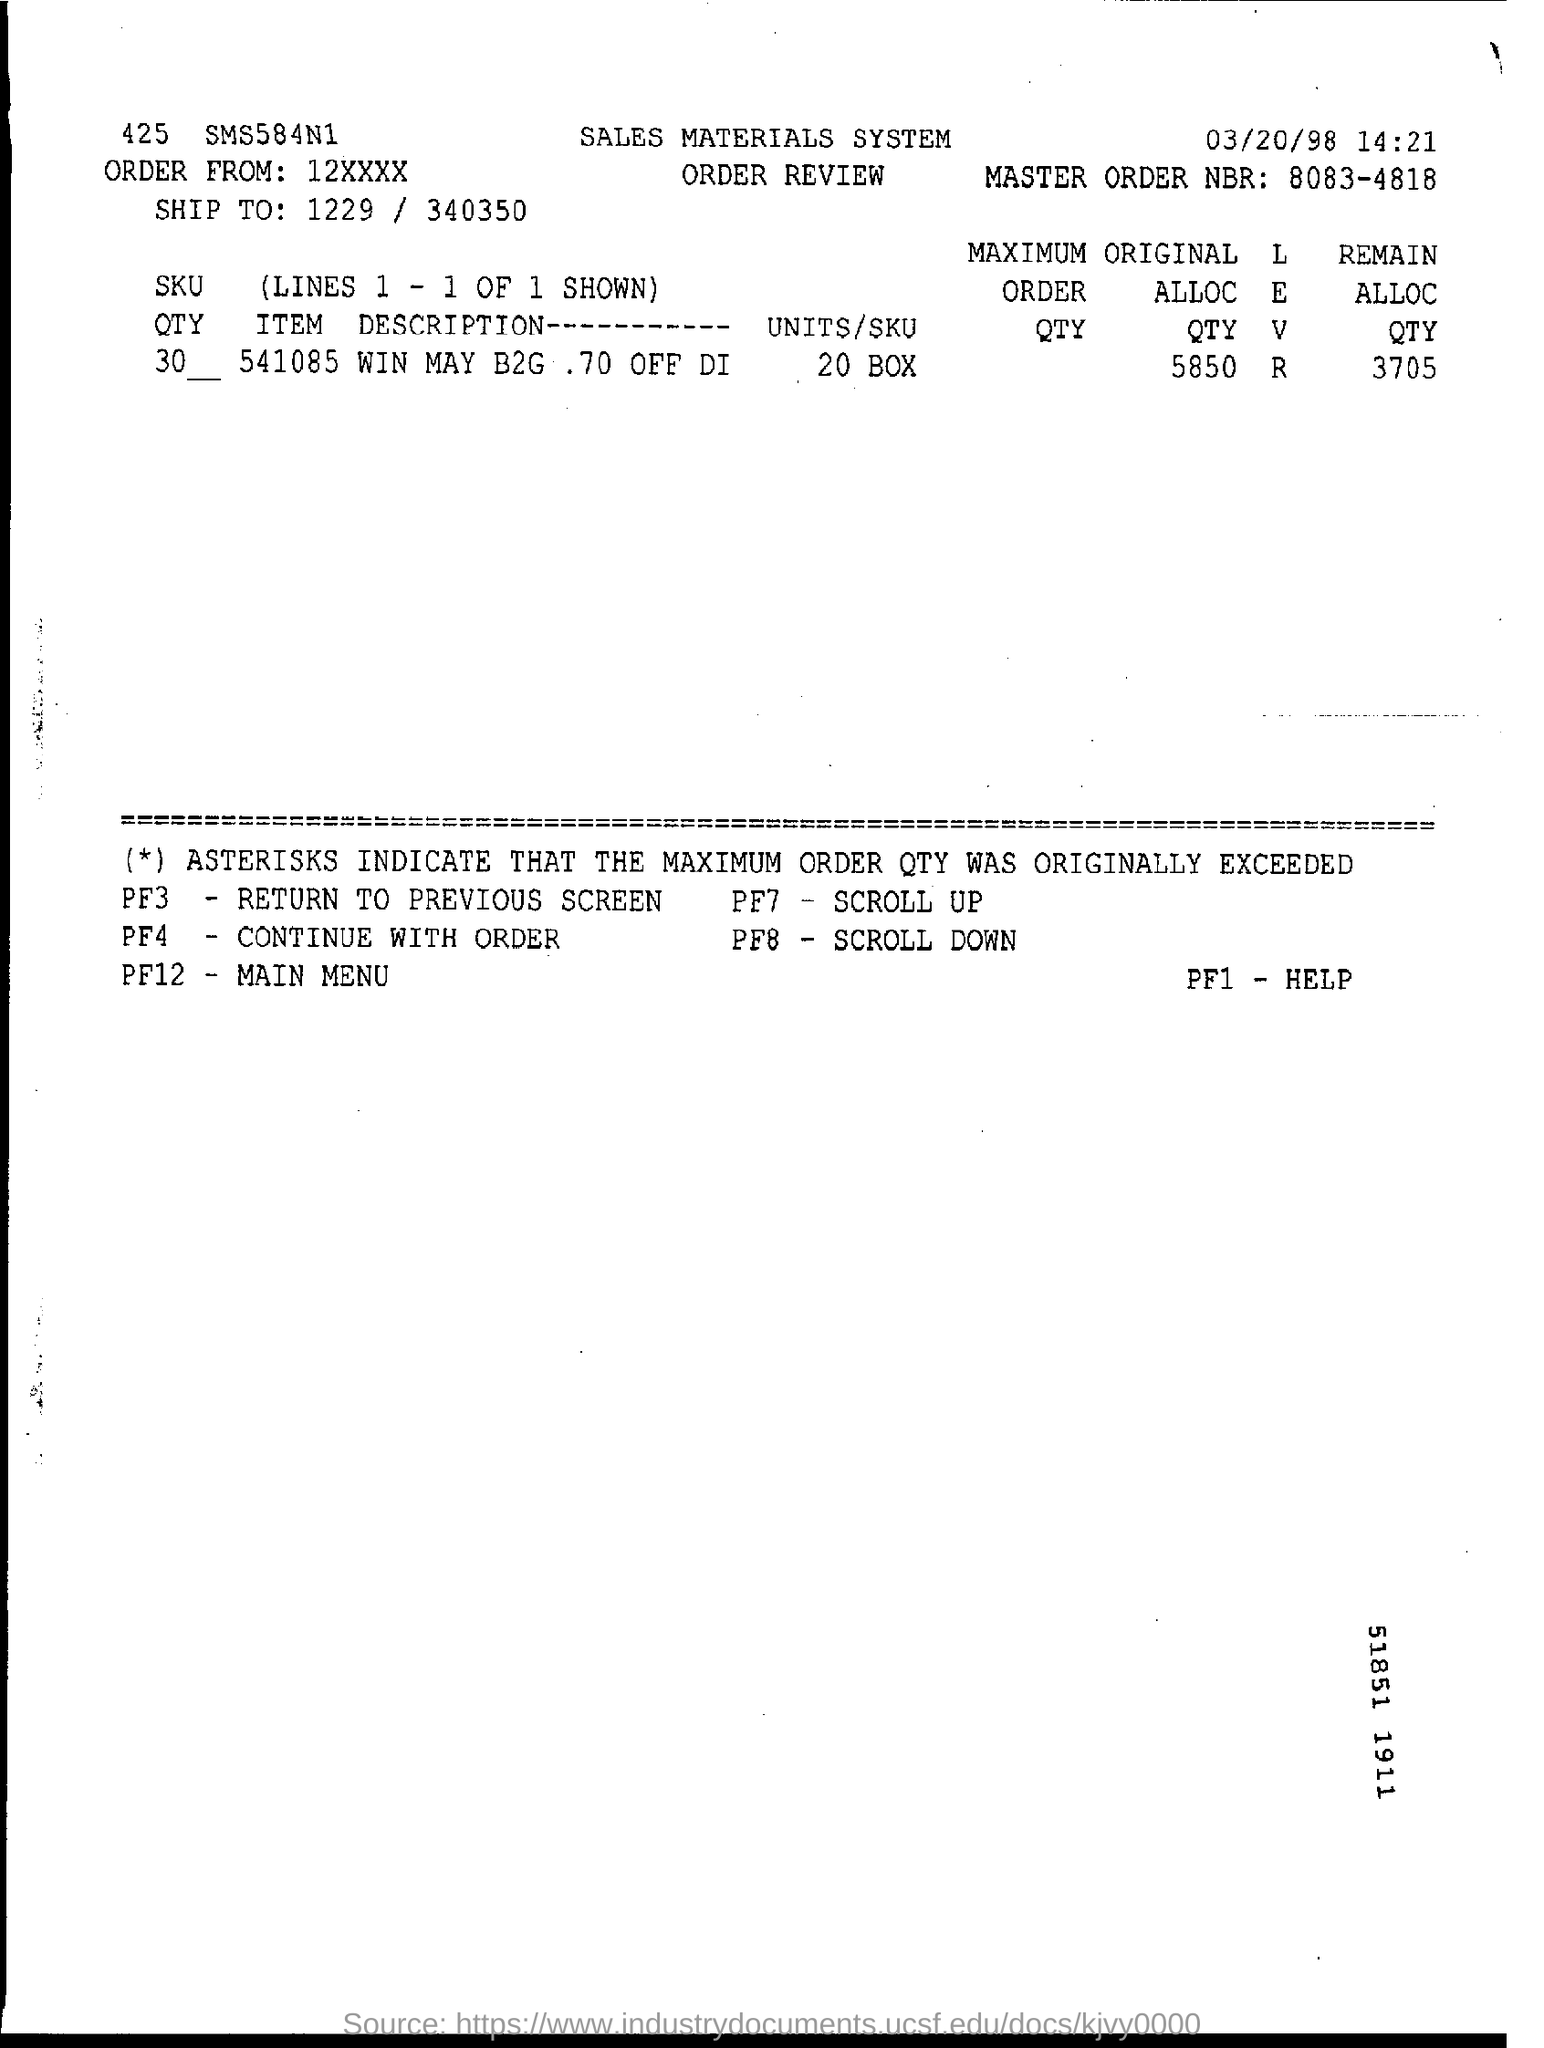What is the master order nbr ?
Your response must be concise. 8083-4818. What is the remain alloc qty ?
Ensure brevity in your answer.  3705. 